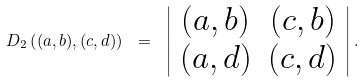<formula> <loc_0><loc_0><loc_500><loc_500>D _ { 2 } \left ( ( a , b ) , ( c , d ) \right ) \ = \ \left | \begin{array} { c c } ( a , b ) & ( c , b ) \\ ( a , d ) & ( c , d ) \end{array} \right | .</formula> 